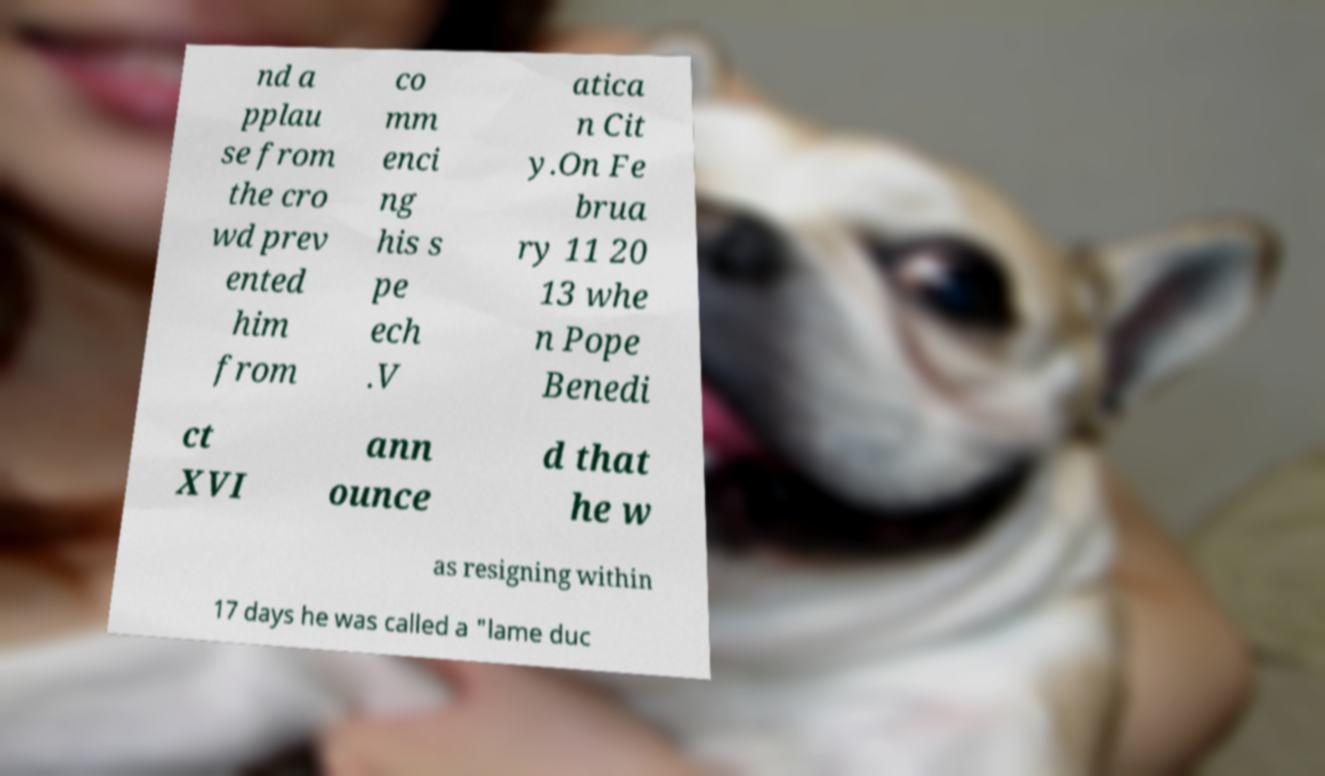What messages or text are displayed in this image? I need them in a readable, typed format. nd a pplau se from the cro wd prev ented him from co mm enci ng his s pe ech .V atica n Cit y.On Fe brua ry 11 20 13 whe n Pope Benedi ct XVI ann ounce d that he w as resigning within 17 days he was called a "lame duc 